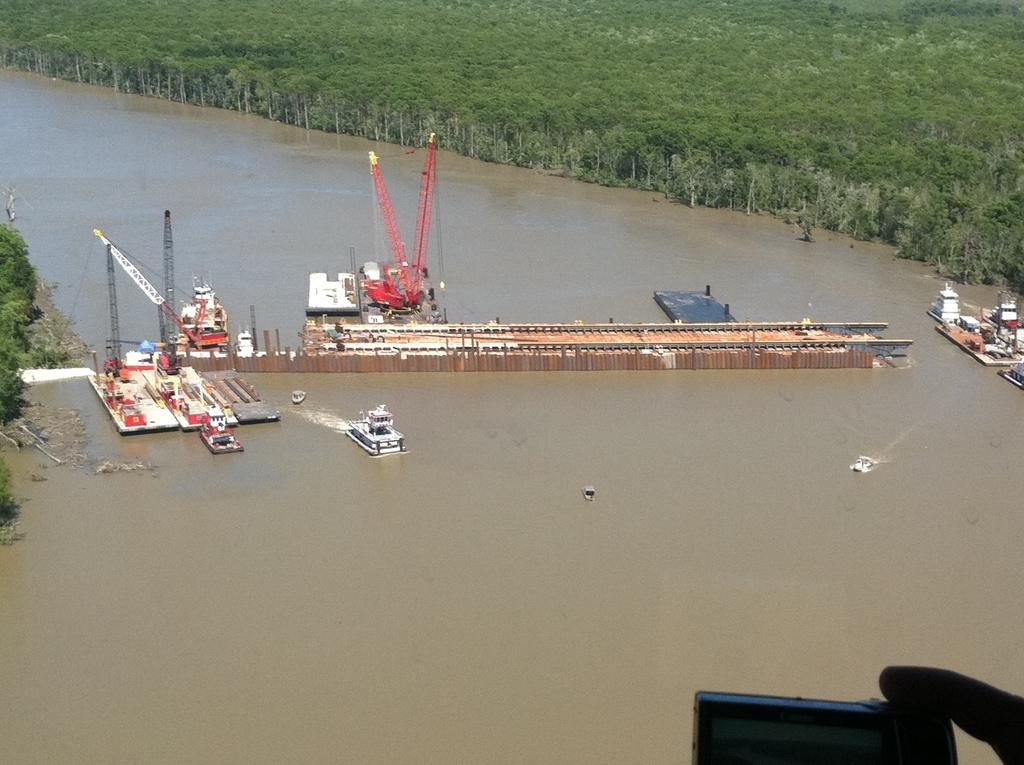What is happening in the middle of the image? A construction is taking place in the middle of the image. What equipment is being used at the construction site? There are cranes present at the construction site. What can be seen in the water in the image? Boats are visible in the water. What type of vegetation is on the right side of the image? There are trees on the right side of the image. What color is the orange that is being used in the construction process in the image? There is no orange present in the image; it is a construction site with cranes and boats, but no orange is mentioned or visible. 